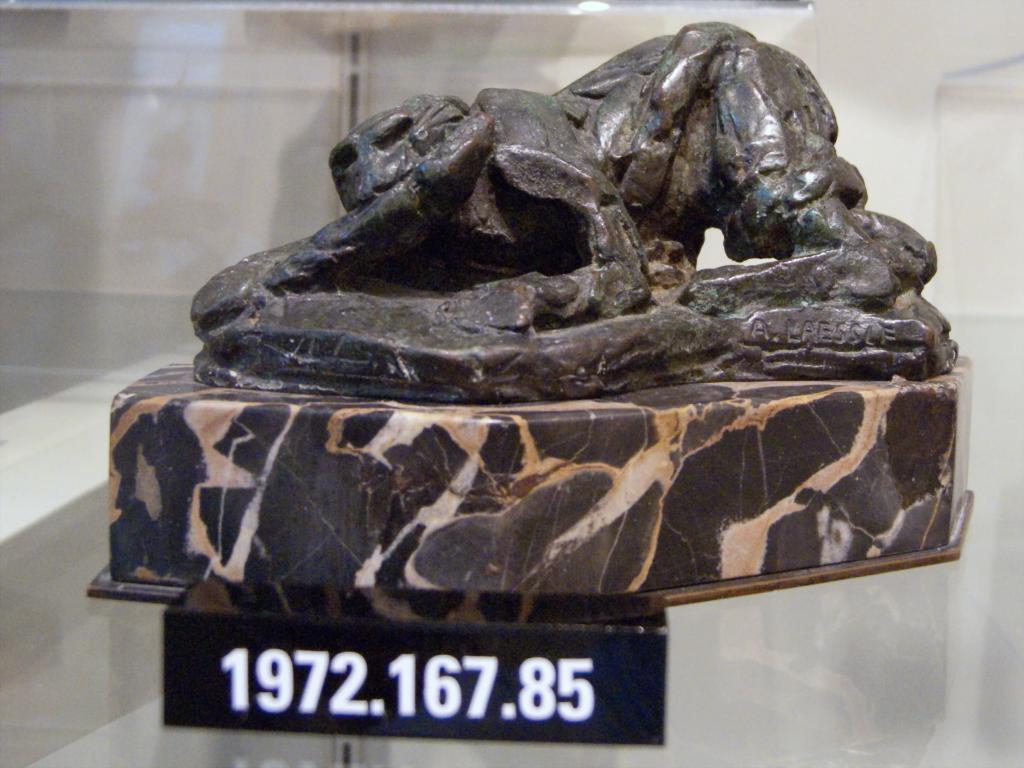Can you describe this image briefly? In the image we can see a sculpture on the stone. Here we can see a board, on it there are numbers. 